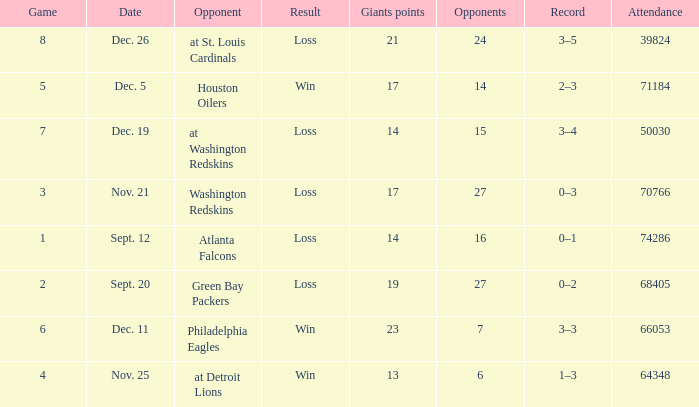What is the record when the opponent is washington redskins? 0–3. 